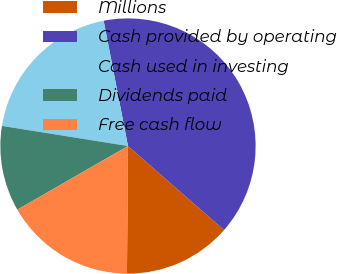Convert chart. <chart><loc_0><loc_0><loc_500><loc_500><pie_chart><fcel>Millions<fcel>Cash provided by operating<fcel>Cash used in investing<fcel>Dividends paid<fcel>Free cash flow<nl><fcel>13.69%<fcel>39.49%<fcel>19.43%<fcel>10.83%<fcel>16.56%<nl></chart> 